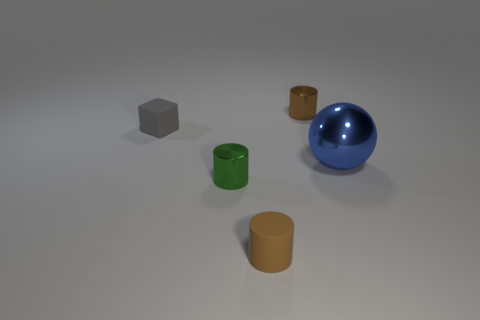Is there any other thing that has the same shape as the small gray matte thing?
Your answer should be very brief. No. Is there anything else that has the same material as the blue object?
Ensure brevity in your answer.  Yes. Are there the same number of green objects to the right of the large sphere and gray rubber blocks that are on the right side of the tiny green shiny cylinder?
Offer a terse response. Yes. Do the ball and the cube have the same material?
Provide a succinct answer. No. What number of blue objects are either large metal things or matte objects?
Offer a very short reply. 1. What number of metallic objects are the same shape as the brown rubber object?
Give a very brief answer. 2. What is the material of the ball?
Provide a succinct answer. Metal. Is the number of gray matte objects to the right of the large blue shiny thing the same as the number of yellow objects?
Provide a succinct answer. Yes. There is a gray object that is the same size as the brown rubber object; what is its shape?
Offer a very short reply. Cube. Are there any tiny brown rubber things behind the brown thing that is behind the small green metal object?
Provide a succinct answer. No. 